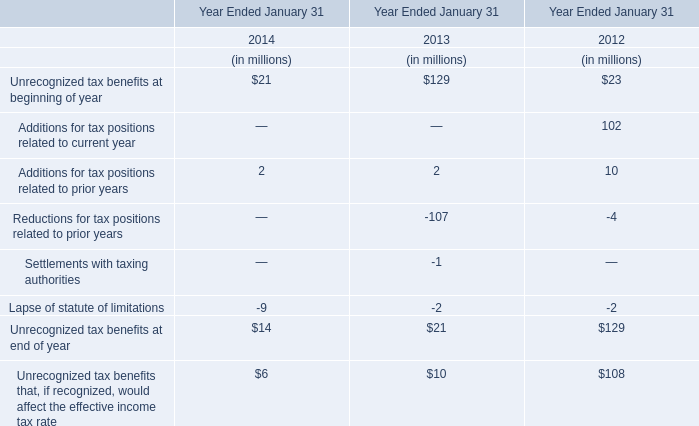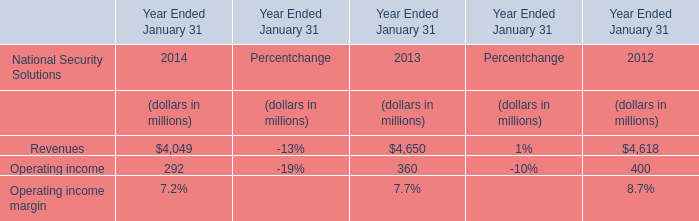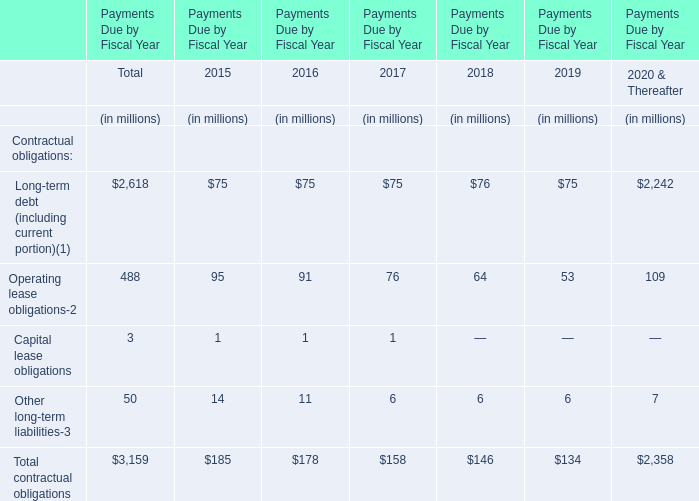What's the total amount of theRevenues in the years where Unrecognized tax benefits at end of year is greater than 14 (in million) 
Computations: (4650 + 4618)
Answer: 9268.0. 